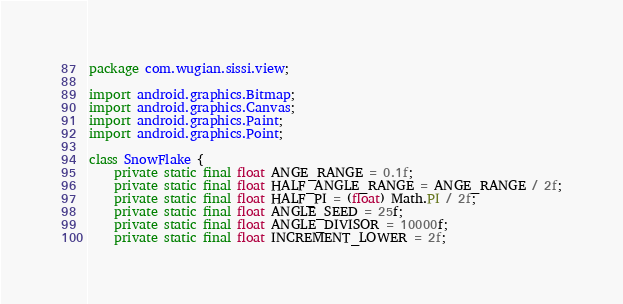Convert code to text. <code><loc_0><loc_0><loc_500><loc_500><_Java_>package com.wugian.sissi.view;

import android.graphics.Bitmap;
import android.graphics.Canvas;
import android.graphics.Paint;
import android.graphics.Point;

class SnowFlake {
    private static final float ANGE_RANGE = 0.1f;
    private static final float HALF_ANGLE_RANGE = ANGE_RANGE / 2f;
    private static final float HALF_PI = (float) Math.PI / 2f;
    private static final float ANGLE_SEED = 25f;
    private static final float ANGLE_DIVISOR = 10000f;
    private static final float INCREMENT_LOWER = 2f;</code> 